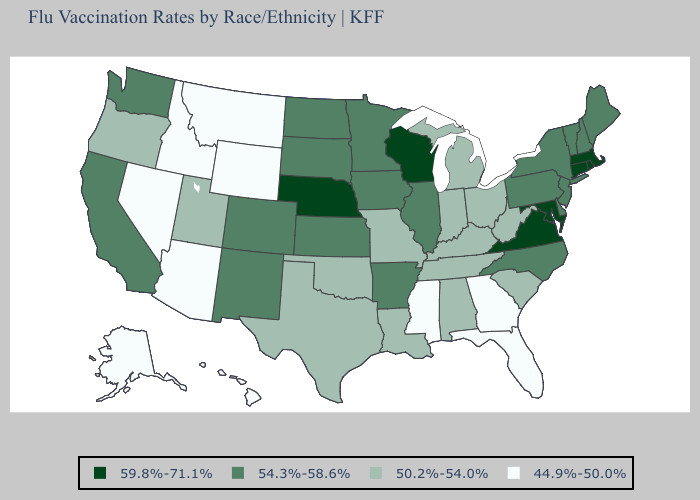Does the first symbol in the legend represent the smallest category?
Quick response, please. No. Does Florida have the highest value in the USA?
Keep it brief. No. How many symbols are there in the legend?
Answer briefly. 4. What is the highest value in the Northeast ?
Be succinct. 59.8%-71.1%. Does Massachusetts have the highest value in the USA?
Give a very brief answer. Yes. What is the value of Illinois?
Quick response, please. 54.3%-58.6%. Name the states that have a value in the range 44.9%-50.0%?
Short answer required. Alaska, Arizona, Florida, Georgia, Hawaii, Idaho, Mississippi, Montana, Nevada, Wyoming. Name the states that have a value in the range 50.2%-54.0%?
Give a very brief answer. Alabama, Indiana, Kentucky, Louisiana, Michigan, Missouri, Ohio, Oklahoma, Oregon, South Carolina, Tennessee, Texas, Utah, West Virginia. Name the states that have a value in the range 59.8%-71.1%?
Give a very brief answer. Connecticut, Maryland, Massachusetts, Nebraska, Rhode Island, Virginia, Wisconsin. Among the states that border Illinois , does Kentucky have the lowest value?
Concise answer only. Yes. Name the states that have a value in the range 50.2%-54.0%?
Write a very short answer. Alabama, Indiana, Kentucky, Louisiana, Michigan, Missouri, Ohio, Oklahoma, Oregon, South Carolina, Tennessee, Texas, Utah, West Virginia. Among the states that border Minnesota , which have the lowest value?
Concise answer only. Iowa, North Dakota, South Dakota. What is the value of Kansas?
Short answer required. 54.3%-58.6%. What is the lowest value in the South?
Short answer required. 44.9%-50.0%. Among the states that border Wyoming , does Utah have the highest value?
Give a very brief answer. No. 